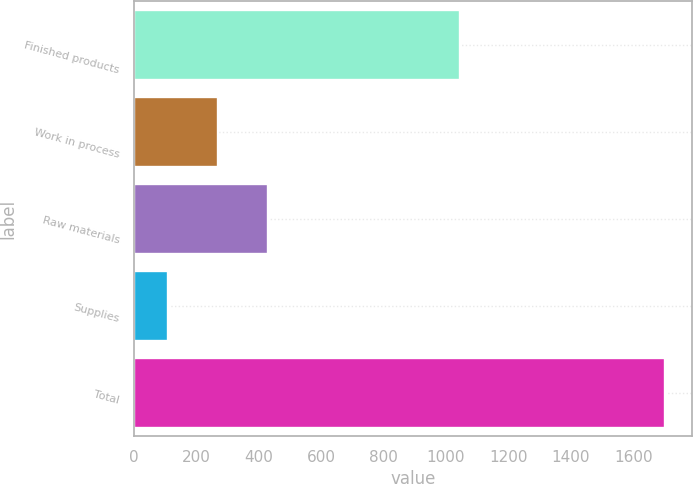Convert chart to OTSL. <chart><loc_0><loc_0><loc_500><loc_500><bar_chart><fcel>Finished products<fcel>Work in process<fcel>Raw materials<fcel>Supplies<fcel>Total<nl><fcel>1045<fcel>270.1<fcel>429.2<fcel>111<fcel>1702<nl></chart> 